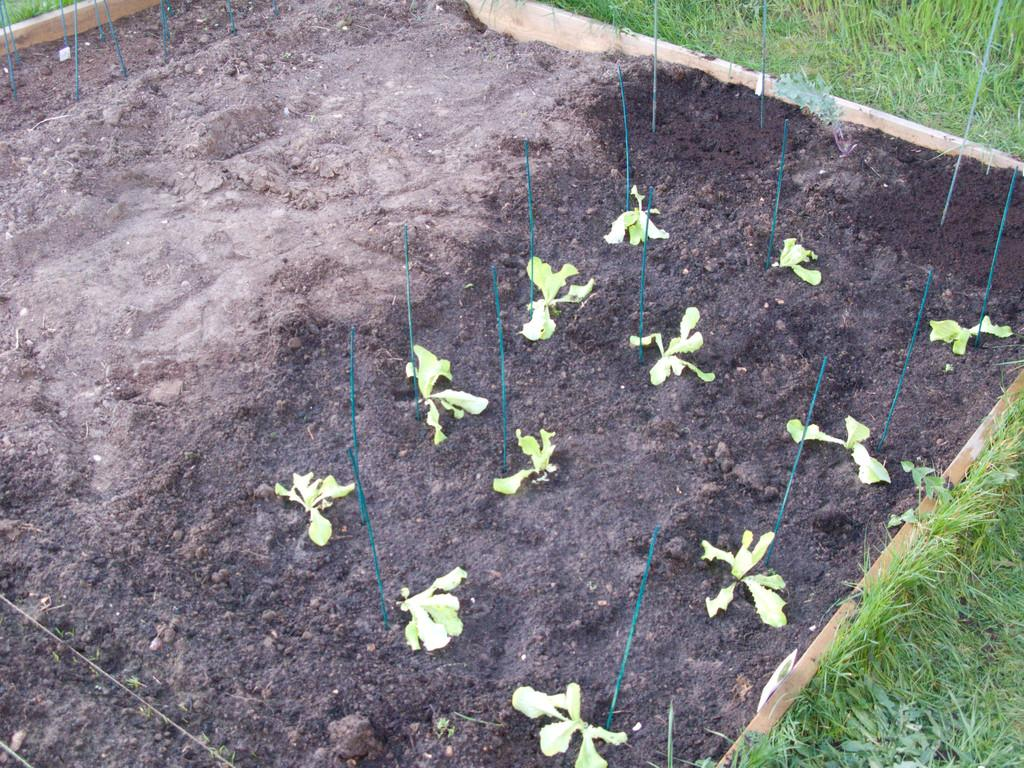What object is present in the image that is used for holding items? There is a wooden tray in the image. What is inside the wooden tray? The wooden tray contains sand. What type of vegetation can be seen in the sand? There are small plants in the sand. What type of vegetation is visible behind the wooden tray? There is grass visible behind the tray. What is the acoustics like in the image? The provided facts do not mention anything about the acoustics in the image, so it cannot be determined from the image. 